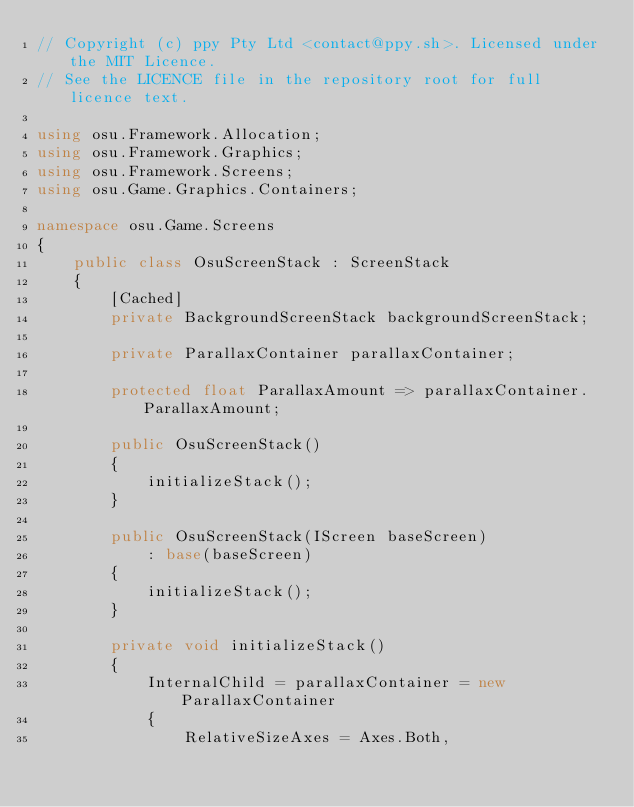<code> <loc_0><loc_0><loc_500><loc_500><_C#_>// Copyright (c) ppy Pty Ltd <contact@ppy.sh>. Licensed under the MIT Licence.
// See the LICENCE file in the repository root for full licence text.

using osu.Framework.Allocation;
using osu.Framework.Graphics;
using osu.Framework.Screens;
using osu.Game.Graphics.Containers;

namespace osu.Game.Screens
{
    public class OsuScreenStack : ScreenStack
    {
        [Cached]
        private BackgroundScreenStack backgroundScreenStack;

        private ParallaxContainer parallaxContainer;

        protected float ParallaxAmount => parallaxContainer.ParallaxAmount;

        public OsuScreenStack()
        {
            initializeStack();
        }

        public OsuScreenStack(IScreen baseScreen)
            : base(baseScreen)
        {
            initializeStack();
        }

        private void initializeStack()
        {
            InternalChild = parallaxContainer = new ParallaxContainer
            {
                RelativeSizeAxes = Axes.Both,</code> 